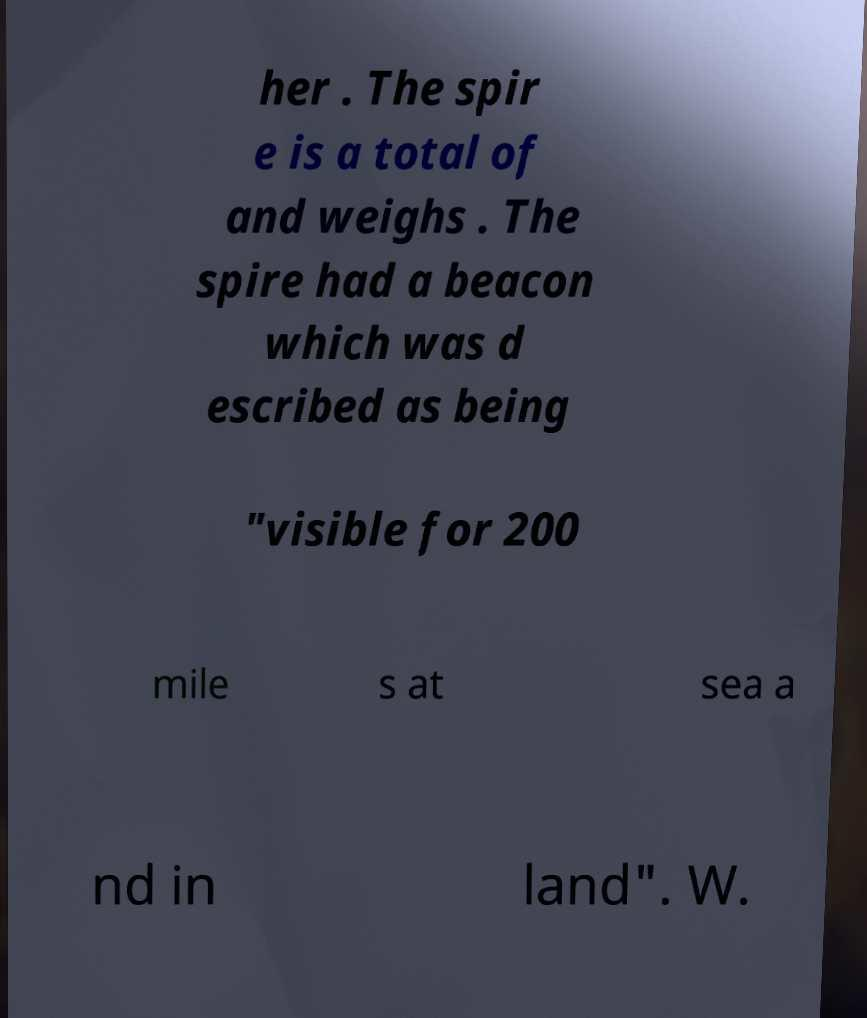For documentation purposes, I need the text within this image transcribed. Could you provide that? her . The spir e is a total of and weighs . The spire had a beacon which was d escribed as being "visible for 200 mile s at sea a nd in land". W. 